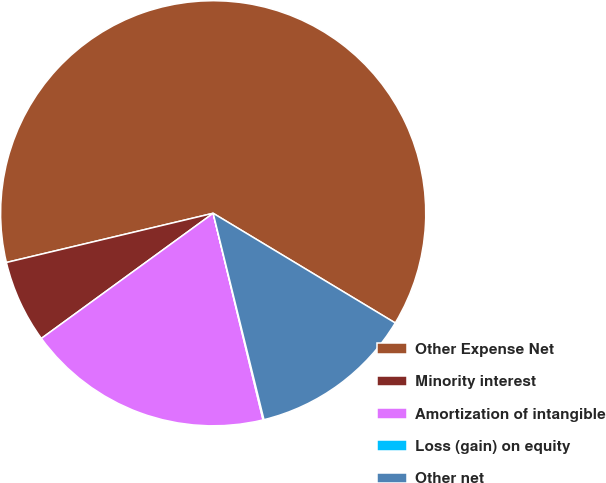Convert chart to OTSL. <chart><loc_0><loc_0><loc_500><loc_500><pie_chart><fcel>Other Expense Net<fcel>Minority interest<fcel>Amortization of intangible<fcel>Loss (gain) on equity<fcel>Other net<nl><fcel>62.35%<fcel>6.3%<fcel>18.75%<fcel>0.07%<fcel>12.53%<nl></chart> 